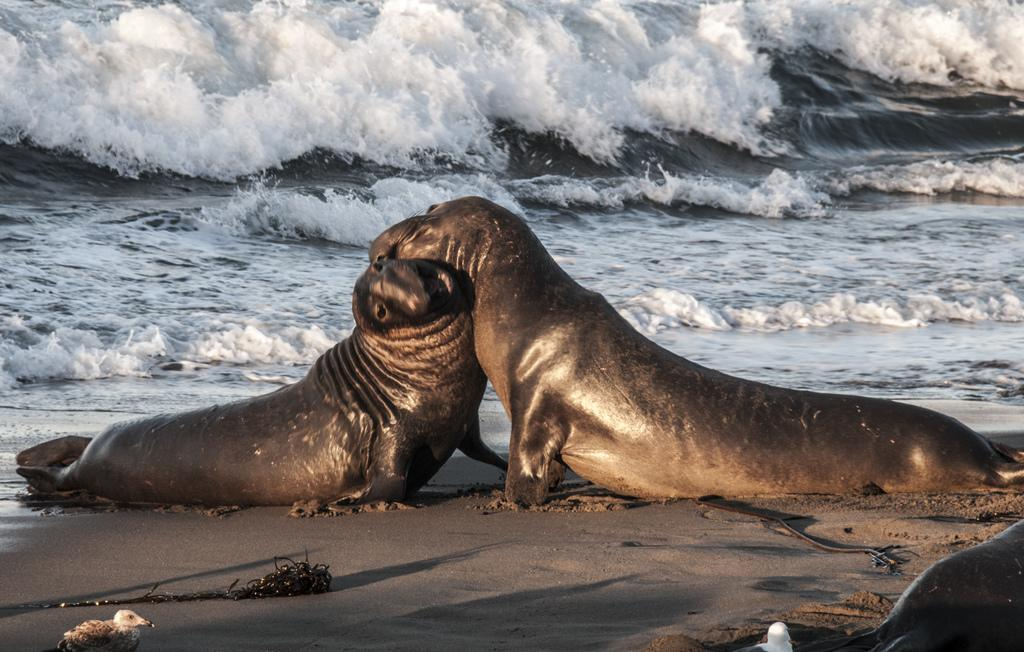How many seals can be seen on the beach in the image? There are three seals on the beach in the image. What is the location of the image? The image is taken near the ocean. When was the image taken? The image was taken during the day. What can be seen in the background of the image? There is water visible in the background of the image. What language is spoken by the seals in the image? Seals do not speak any human language, so it is not possible to determine the language spoken by the seals in the image. 